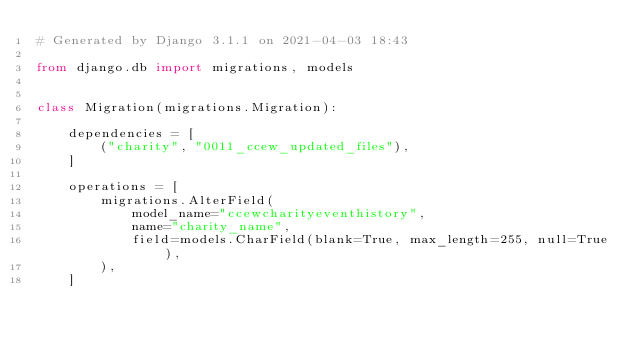<code> <loc_0><loc_0><loc_500><loc_500><_Python_># Generated by Django 3.1.1 on 2021-04-03 18:43

from django.db import migrations, models


class Migration(migrations.Migration):

    dependencies = [
        ("charity", "0011_ccew_updated_files"),
    ]

    operations = [
        migrations.AlterField(
            model_name="ccewcharityeventhistory",
            name="charity_name",
            field=models.CharField(blank=True, max_length=255, null=True),
        ),
    ]
</code> 